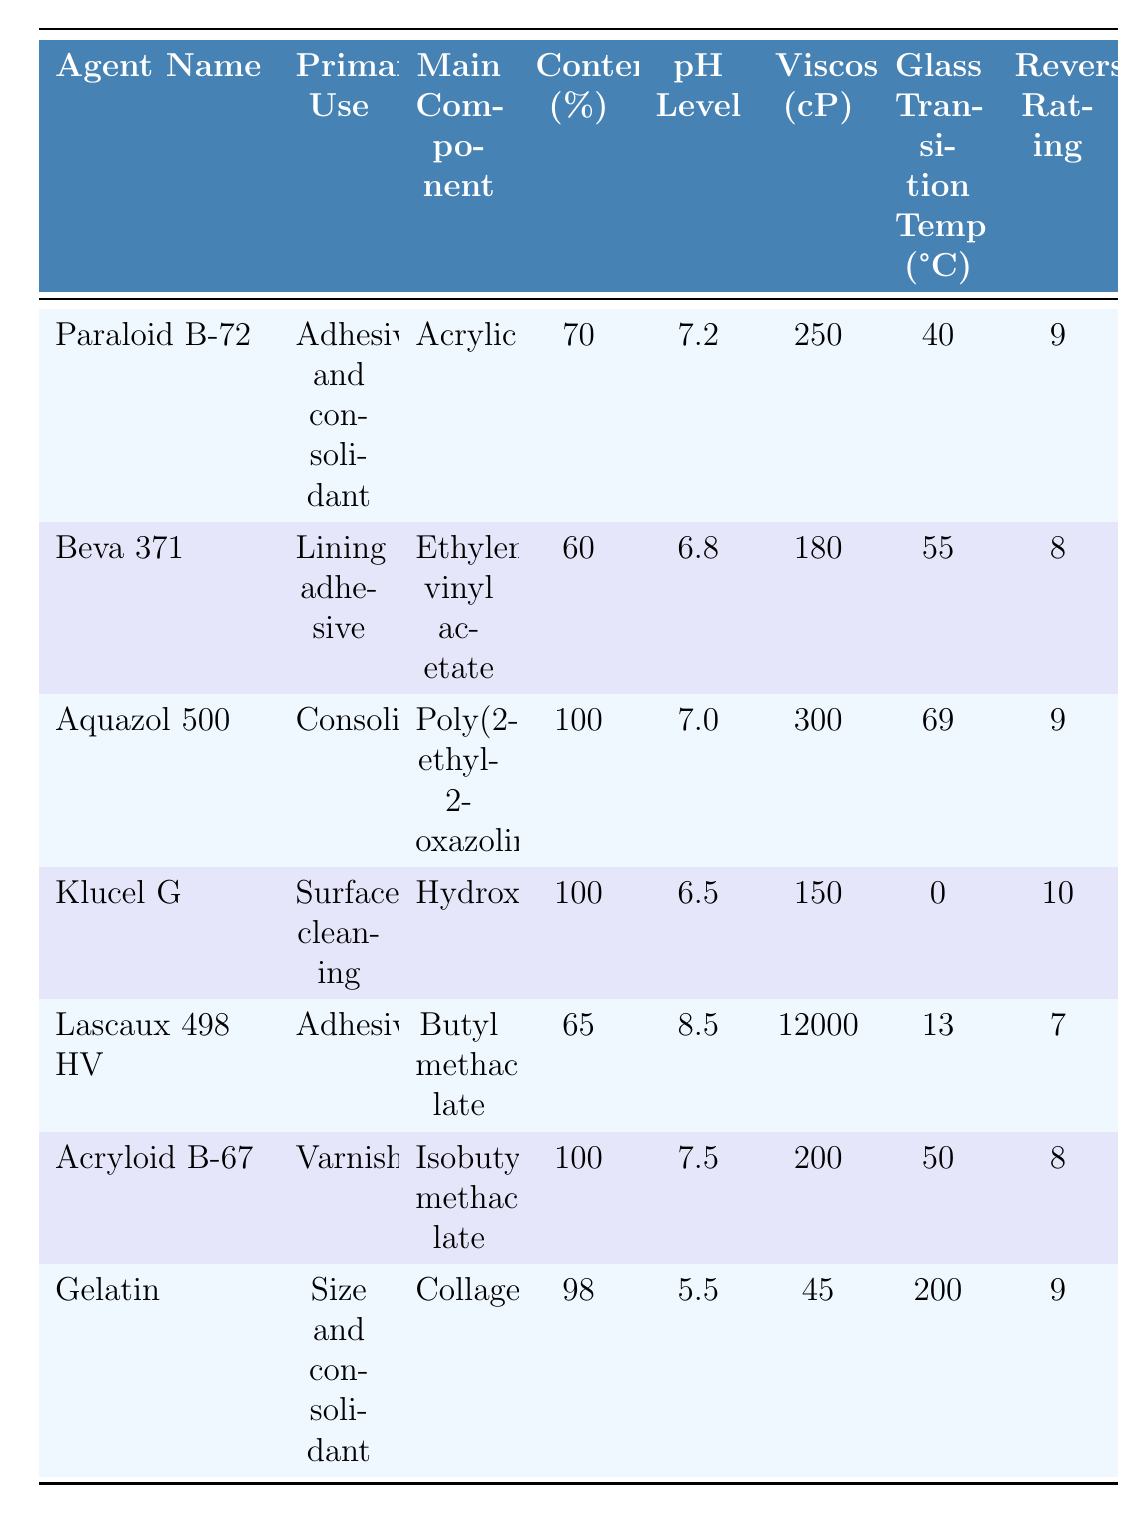What is the pH level of Aquazol 500? The table lists the pH level of Aquazol 500 as 7.0.
Answer: 7.0 Which preservation agent has the highest viscosity? By reviewing the viscosity values, Lascaux 498 HV has a viscosity of 12000, which is higher than all other agents listed.
Answer: Lascaux 498 HV What is the primary use of Klucel G? The table specifies that Klucel G is used for surface cleaning.
Answer: Surface cleaning Calculate the average pH level of all the preservation agents. The pH levels are: 7.2, 6.8, 7.0, 6.5, 8.5, 7.5, and 5.5. Summing these values gives 49.0, and dividing by 7 (the number of agents) results in an average of 7.0.
Answer: 7.0 Is the glass transition temperature of Gelatin greater than 50°C? The glass transition temperature of Gelatin is 200°C, which is indeed greater than 50°C.
Answer: Yes Which agent has a reversibility rating of 10, and what is its primary use? The agent with a reversibility rating of 10 is Klucel G, whose primary use is surface cleaning.
Answer: Klucel G; Surface cleaning What is the total acrylic content from all agents? Only Paraloid B-72 and Acryloid B-67 contain acrylic. Their respective contents are 70% and 100%. Thus, the total acrylic content is 70 + 100 = 170%.
Answer: 170% Identify the agent with the lowest pH level. Comparing the pH levels, Gelatin has the lowest at 5.5.
Answer: Gelatin Which preservation agent is used as a lining adhesive and has a ketone resin content? Beva 371 is identified as a lining adhesive and contains a ketone resin at 20%.
Answer: Beva 371 What is the difference in glass transition temperatures between Aquazol 500 and Lascaux 498 HV? The glass transition temperature of Aquazol 500 is 69°C and for Lascaux 498 HV, it’s 13°C. The difference is 69 - 13 = 56°C.
Answer: 56°C 